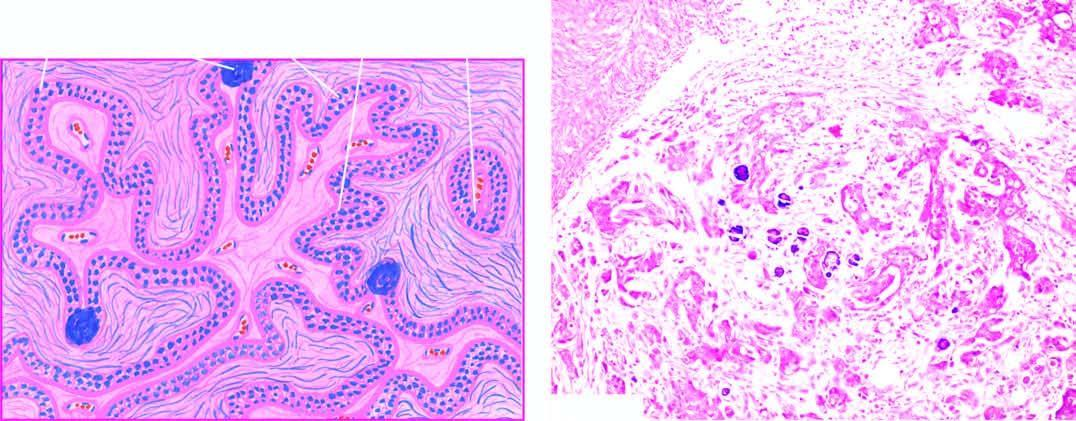what do microscopic features include?
Answer the question using a single word or phrase. Stratification of low columnar epithelium lining the inner surface of the cyst and a few psammoma bodies 